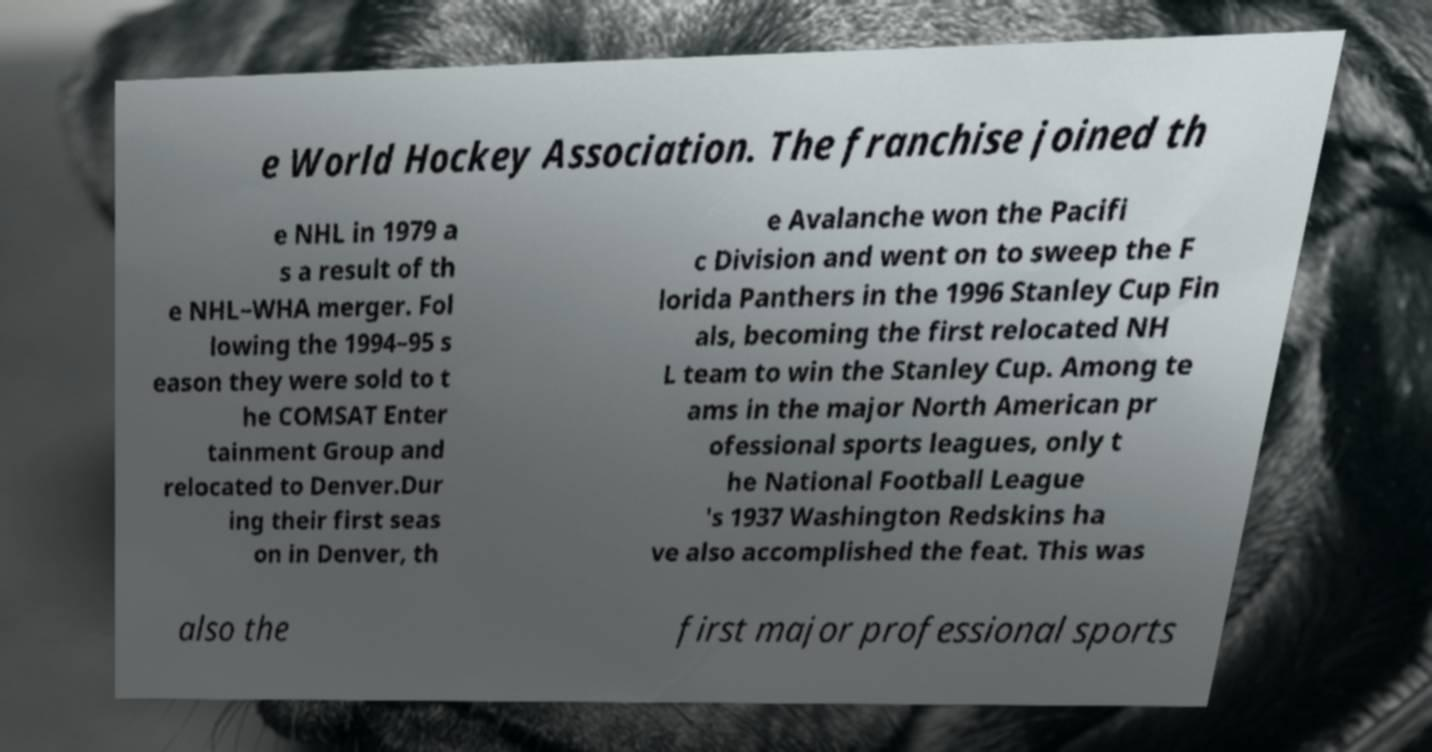For documentation purposes, I need the text within this image transcribed. Could you provide that? e World Hockey Association. The franchise joined th e NHL in 1979 a s a result of th e NHL–WHA merger. Fol lowing the 1994–95 s eason they were sold to t he COMSAT Enter tainment Group and relocated to Denver.Dur ing their first seas on in Denver, th e Avalanche won the Pacifi c Division and went on to sweep the F lorida Panthers in the 1996 Stanley Cup Fin als, becoming the first relocated NH L team to win the Stanley Cup. Among te ams in the major North American pr ofessional sports leagues, only t he National Football League 's 1937 Washington Redskins ha ve also accomplished the feat. This was also the first major professional sports 